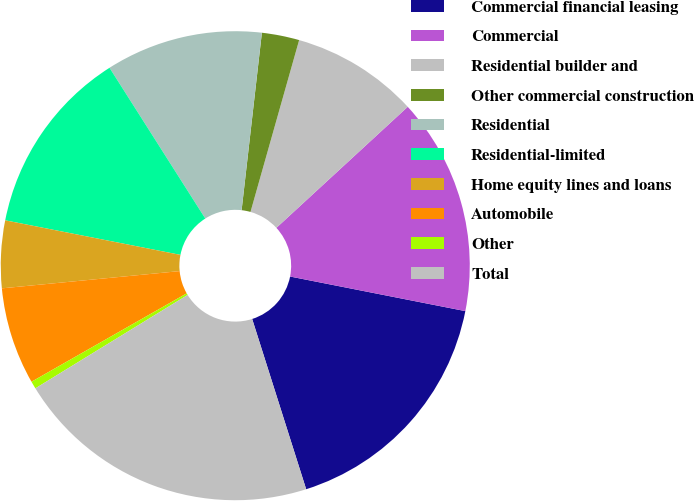Convert chart. <chart><loc_0><loc_0><loc_500><loc_500><pie_chart><fcel>Commercial financial leasing<fcel>Commercial<fcel>Residential builder and<fcel>Other commercial construction<fcel>Residential<fcel>Residential-limited<fcel>Home equity lines and loans<fcel>Automobile<fcel>Other<fcel>Total<nl><fcel>17.01%<fcel>14.95%<fcel>8.76%<fcel>2.58%<fcel>10.82%<fcel>12.89%<fcel>4.64%<fcel>6.7%<fcel>0.52%<fcel>21.13%<nl></chart> 